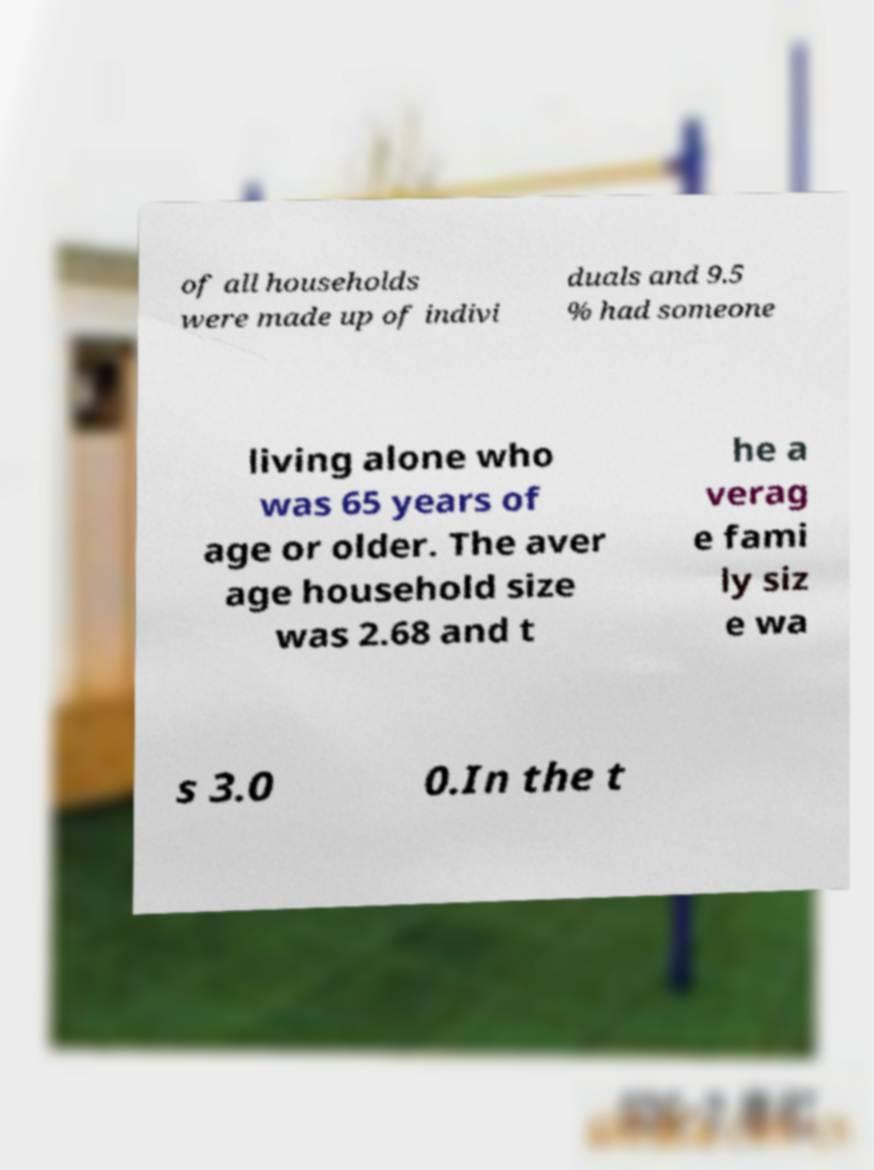Can you read and provide the text displayed in the image?This photo seems to have some interesting text. Can you extract and type it out for me? of all households were made up of indivi duals and 9.5 % had someone living alone who was 65 years of age or older. The aver age household size was 2.68 and t he a verag e fami ly siz e wa s 3.0 0.In the t 